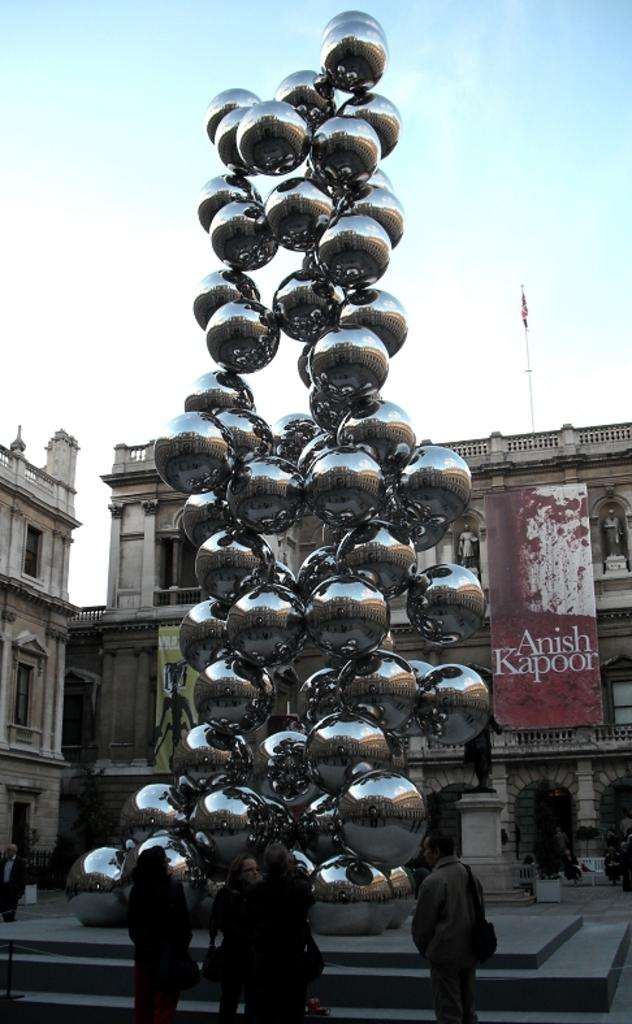What can be seen in the image involving people? There are people standing in the image. What type of sculpture is present in the image? There is a spherical sculpture in the image. What can be seen in the distance in the image? There are buildings in the background of the image. What is hanging or displayed in the image? There is a banner in the image. What is the condition of the sky in the image? The sky is clear in the image. What type of ground is visible beneath the people in the image? There is no specific mention of the ground in the provided facts, so we cannot determine the type of ground visible beneath the people in the image. What kind of friction can be observed between the people and the spherical sculpture in the image? There is no information about friction or any interaction between the people and the sculpture in the provided facts, so we cannot determine the type of friction present. 